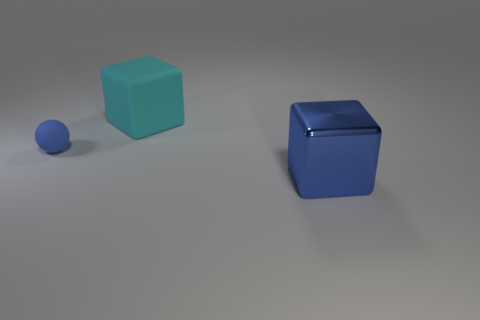Is there anything else that has the same material as the small blue sphere?
Provide a short and direct response. Yes. Is there anything else that has the same size as the blue rubber ball?
Give a very brief answer. No. Are there any other things that have the same color as the tiny sphere?
Your answer should be compact. Yes. What number of other objects are there of the same color as the large shiny object?
Your answer should be very brief. 1. Is the shape of the large blue object the same as the big matte object?
Offer a terse response. Yes. Are there any other things that are the same shape as the small blue object?
Give a very brief answer. No. Are any tiny yellow rubber cubes visible?
Ensure brevity in your answer.  No. Do the big cyan object and the blue thing in front of the tiny object have the same shape?
Offer a terse response. Yes. There is a big block right of the thing that is behind the small matte sphere; what is its material?
Your response must be concise. Metal. What is the color of the matte sphere?
Keep it short and to the point. Blue. 